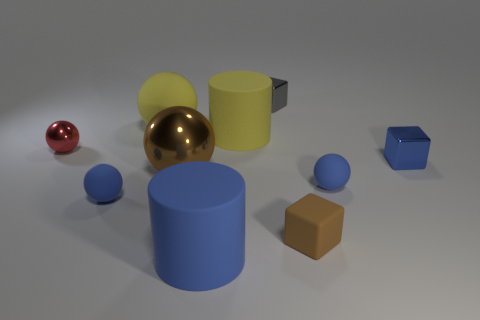Does the tiny matte block have the same color as the big shiny sphere?
Ensure brevity in your answer.  Yes. There is a blue thing that is the same shape as the small gray metal thing; what material is it?
Your answer should be very brief. Metal. What material is the brown object that is left of the small brown block?
Your response must be concise. Metal. There is a large thing that is the same color as the matte block; what is its shape?
Give a very brief answer. Sphere. The blue object that is behind the small blue matte object right of the tiny gray metallic block is made of what material?
Provide a succinct answer. Metal. Do the matte ball behind the tiny shiny sphere and the matte cylinder behind the red sphere have the same color?
Your answer should be compact. Yes. Is there a big metal sphere of the same color as the tiny rubber block?
Provide a succinct answer. Yes. Do the metal block that is in front of the yellow matte cylinder and the large metal sphere have the same size?
Provide a succinct answer. No. Are there an equal number of big balls on the right side of the blue matte cylinder and small metallic spheres?
Provide a succinct answer. No. What number of objects are blue balls to the left of the brown metal sphere or large gray matte blocks?
Your answer should be very brief. 1. 